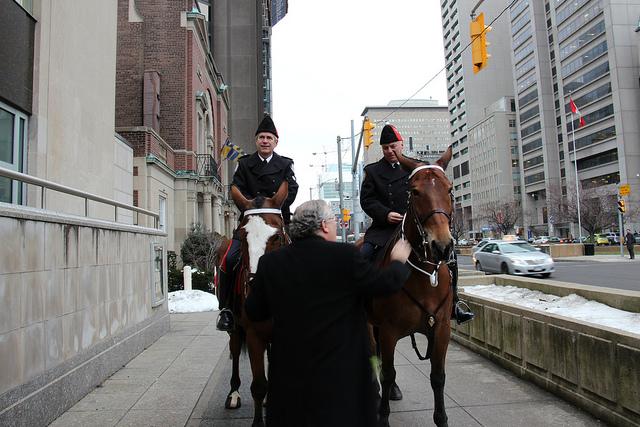Could these men on horses be with law enforcement?
Concise answer only. Yes. What season is it in this picture?
Quick response, please. Winter. How many horses are there?
Give a very brief answer. 2. 